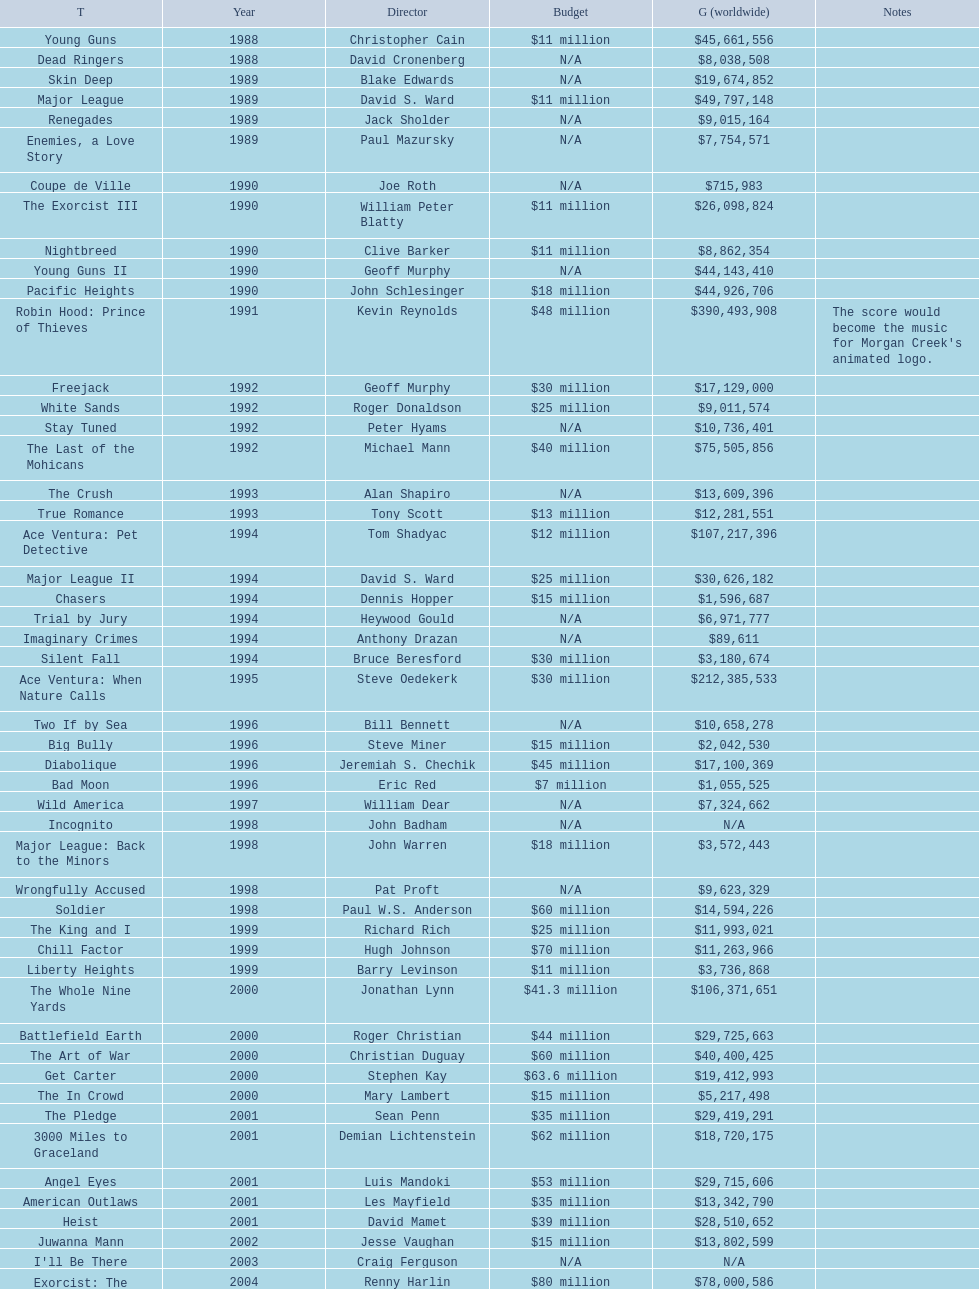Could you help me parse every detail presented in this table? {'header': ['T', 'Year', 'Director', 'Budget', 'G (worldwide)', 'Notes'], 'rows': [['Young Guns', '1988', 'Christopher Cain', '$11 million', '$45,661,556', ''], ['Dead Ringers', '1988', 'David Cronenberg', 'N/A', '$8,038,508', ''], ['Skin Deep', '1989', 'Blake Edwards', 'N/A', '$19,674,852', ''], ['Major League', '1989', 'David S. Ward', '$11 million', '$49,797,148', ''], ['Renegades', '1989', 'Jack Sholder', 'N/A', '$9,015,164', ''], ['Enemies, a Love Story', '1989', 'Paul Mazursky', 'N/A', '$7,754,571', ''], ['Coupe de Ville', '1990', 'Joe Roth', 'N/A', '$715,983', ''], ['The Exorcist III', '1990', 'William Peter Blatty', '$11 million', '$26,098,824', ''], ['Nightbreed', '1990', 'Clive Barker', '$11 million', '$8,862,354', ''], ['Young Guns II', '1990', 'Geoff Murphy', 'N/A', '$44,143,410', ''], ['Pacific Heights', '1990', 'John Schlesinger', '$18 million', '$44,926,706', ''], ['Robin Hood: Prince of Thieves', '1991', 'Kevin Reynolds', '$48 million', '$390,493,908', "The score would become the music for Morgan Creek's animated logo."], ['Freejack', '1992', 'Geoff Murphy', '$30 million', '$17,129,000', ''], ['White Sands', '1992', 'Roger Donaldson', '$25 million', '$9,011,574', ''], ['Stay Tuned', '1992', 'Peter Hyams', 'N/A', '$10,736,401', ''], ['The Last of the Mohicans', '1992', 'Michael Mann', '$40 million', '$75,505,856', ''], ['The Crush', '1993', 'Alan Shapiro', 'N/A', '$13,609,396', ''], ['True Romance', '1993', 'Tony Scott', '$13 million', '$12,281,551', ''], ['Ace Ventura: Pet Detective', '1994', 'Tom Shadyac', '$12 million', '$107,217,396', ''], ['Major League II', '1994', 'David S. Ward', '$25 million', '$30,626,182', ''], ['Chasers', '1994', 'Dennis Hopper', '$15 million', '$1,596,687', ''], ['Trial by Jury', '1994', 'Heywood Gould', 'N/A', '$6,971,777', ''], ['Imaginary Crimes', '1994', 'Anthony Drazan', 'N/A', '$89,611', ''], ['Silent Fall', '1994', 'Bruce Beresford', '$30 million', '$3,180,674', ''], ['Ace Ventura: When Nature Calls', '1995', 'Steve Oedekerk', '$30 million', '$212,385,533', ''], ['Two If by Sea', '1996', 'Bill Bennett', 'N/A', '$10,658,278', ''], ['Big Bully', '1996', 'Steve Miner', '$15 million', '$2,042,530', ''], ['Diabolique', '1996', 'Jeremiah S. Chechik', '$45 million', '$17,100,369', ''], ['Bad Moon', '1996', 'Eric Red', '$7 million', '$1,055,525', ''], ['Wild America', '1997', 'William Dear', 'N/A', '$7,324,662', ''], ['Incognito', '1998', 'John Badham', 'N/A', 'N/A', ''], ['Major League: Back to the Minors', '1998', 'John Warren', '$18 million', '$3,572,443', ''], ['Wrongfully Accused', '1998', 'Pat Proft', 'N/A', '$9,623,329', ''], ['Soldier', '1998', 'Paul W.S. Anderson', '$60 million', '$14,594,226', ''], ['The King and I', '1999', 'Richard Rich', '$25 million', '$11,993,021', ''], ['Chill Factor', '1999', 'Hugh Johnson', '$70 million', '$11,263,966', ''], ['Liberty Heights', '1999', 'Barry Levinson', '$11 million', '$3,736,868', ''], ['The Whole Nine Yards', '2000', 'Jonathan Lynn', '$41.3 million', '$106,371,651', ''], ['Battlefield Earth', '2000', 'Roger Christian', '$44 million', '$29,725,663', ''], ['The Art of War', '2000', 'Christian Duguay', '$60 million', '$40,400,425', ''], ['Get Carter', '2000', 'Stephen Kay', '$63.6 million', '$19,412,993', ''], ['The In Crowd', '2000', 'Mary Lambert', '$15 million', '$5,217,498', ''], ['The Pledge', '2001', 'Sean Penn', '$35 million', '$29,419,291', ''], ['3000 Miles to Graceland', '2001', 'Demian Lichtenstein', '$62 million', '$18,720,175', ''], ['Angel Eyes', '2001', 'Luis Mandoki', '$53 million', '$29,715,606', ''], ['American Outlaws', '2001', 'Les Mayfield', '$35 million', '$13,342,790', ''], ['Heist', '2001', 'David Mamet', '$39 million', '$28,510,652', ''], ['Juwanna Mann', '2002', 'Jesse Vaughan', '$15 million', '$13,802,599', ''], ["I'll Be There", '2003', 'Craig Ferguson', 'N/A', 'N/A', ''], ['Exorcist: The Beginning', '2004', 'Renny Harlin', '$80 million', '$78,000,586', ''], ['Dominion: Prequel to the Exorcist', '2005', 'Paul Schrader', '$30 million', '$251,495', ''], ['Two for the Money', '2005', 'D. J. Caruso', '$25 million', '$30,526,509', ''], ['Man of the Year', '2006', 'Barry Levinson', '$20 million', '$41,237,658', ''], ['The Good Shepherd', '2006', 'Robert De Niro', '$85 million', '$99,480,480', ''], ['Georgia Rule', '2007', 'Garry Marshall', '$20 million', '$25,992,167', ''], ['Sydney White', '2007', 'Joe Nussbaum', 'N/A', '$13,620,075', ''], ['Ace Ventura Jr: Pet Detective', '2009', 'David Mickey Evans', '$7.5 million', 'N/A', ''], ['Dream House', '2011', 'Jim Sheridan', '$50 million', '$38,502,340', ''], ['The Thing', '2011', 'Matthijs van Heijningen Jr.', '$38 million', '$27,428,670', ''], ['Tupac', '2014', 'Antoine Fuqua', '$45 million', '', '']]} Was the budget allocated to young guns higher or lower than that of freejack? Less. 